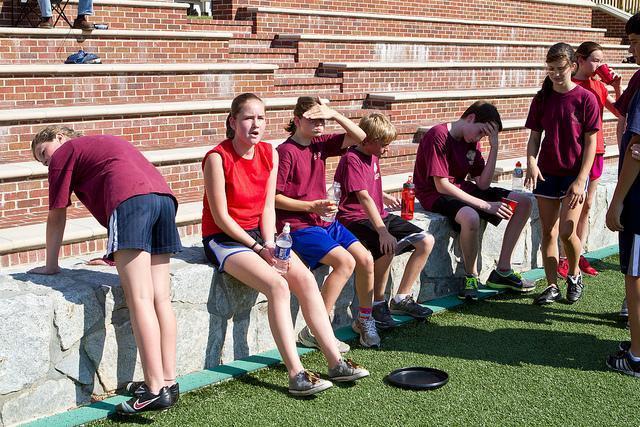How many women are sitting on the cement?
Give a very brief answer. 2. How many people are there?
Give a very brief answer. 4. How many ovens are there?
Give a very brief answer. 0. 